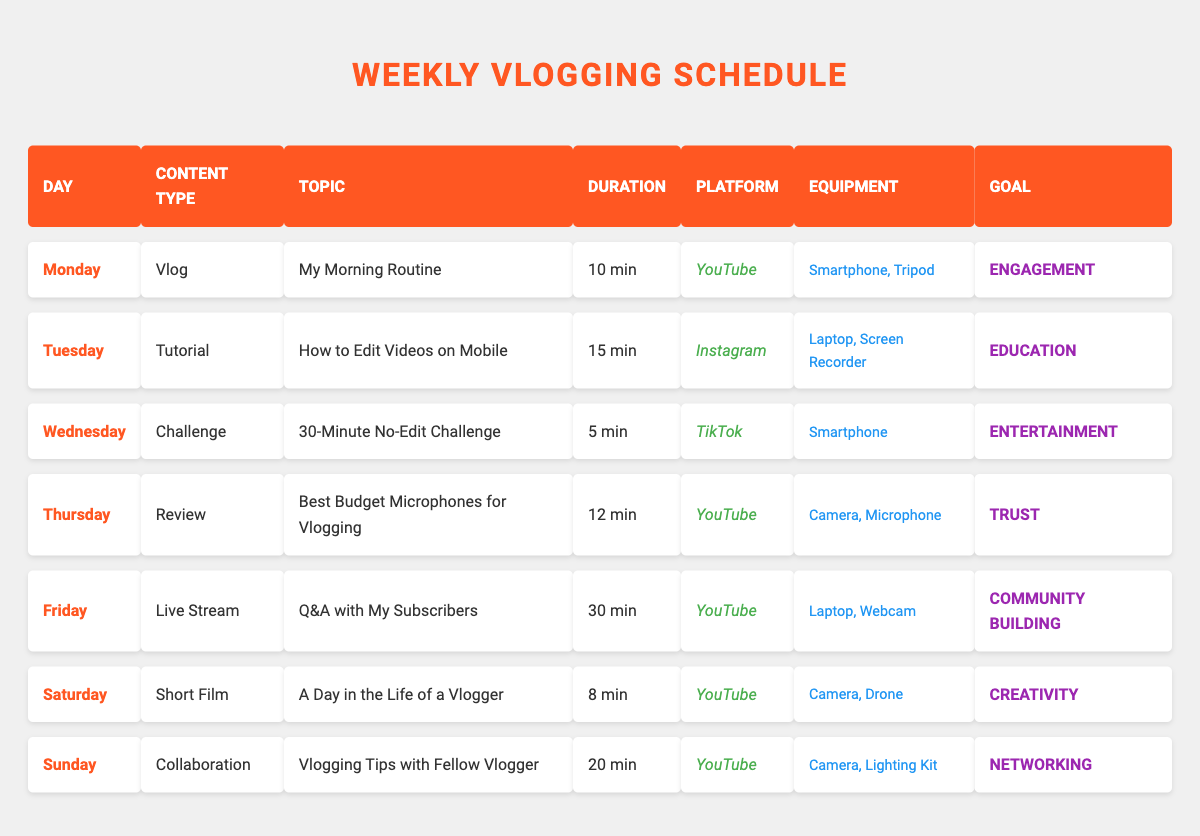What is the total duration of content created on Saturday? The content created on Saturday is a Short Film titled "A Day in the Life of a Vlogger," which has a duration of 8 minutes. Therefore, the total duration is 8 minutes.
Answer: 8 minutes What type of content is produced on Wednesday? The content type produced on Wednesday is a Challenge. Specifically, the topic is "30-Minute No-Edit Challenge."
Answer: Challenge Which platform is used for the Live Stream on Friday? The platform used for the Live Stream on Friday is YouTube, as stated in the corresponding row for that day.
Answer: YouTube Is the goal of the content created on Monday focused on Education? The goal of the content created on Monday is Engagement, as indicated in the table. Therefore, the statement is false.
Answer: No What is the average duration of content created throughout the week? The durations for each day are: 10, 15, 5, 12, 30, 8, and 20 minutes. To find the average: first sum these values: 10 + 15 + 5 + 12 + 30 + 8 + 20 = 110 minutes. Then, divide by the number of days (7): 110/7 = 15.71 minutes.
Answer: 15.71 minutes What content type has the longest duration, and how long is it? The content type with the longest duration is the Live Stream on Friday, lasting 30 minutes. This is checked by comparing all durations in the table.
Answer: Live Stream, 30 minutes On which day is the Vlog format used, and what is its topic? The Vlog format is used on Monday with the topic "My Morning Routine," as indicated in the respective row for that day.
Answer: Monday, My Morning Routine Does the equipment for creating content on Sunday include a Tripod? The equipment listed for Sunday includes a Camera and Lighting Kit but does not include a Tripod. Therefore, the statement is false.
Answer: No 